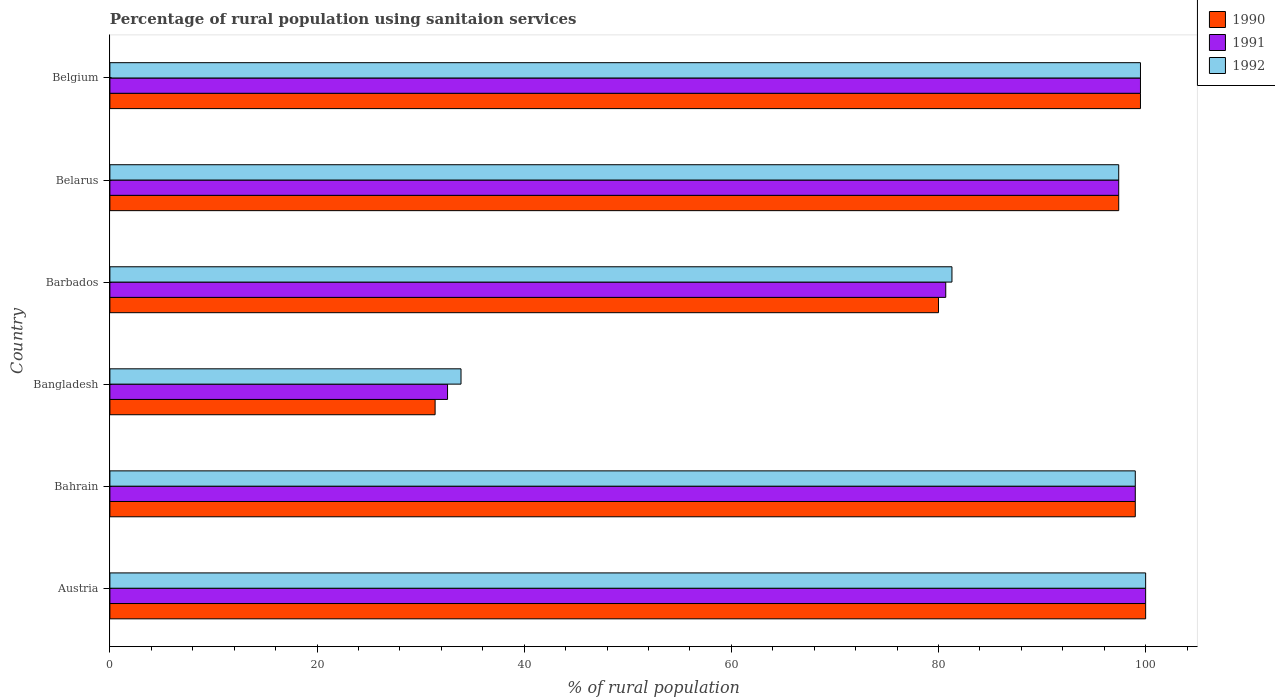Are the number of bars per tick equal to the number of legend labels?
Your answer should be very brief. Yes. How many bars are there on the 4th tick from the bottom?
Give a very brief answer. 3. Across all countries, what is the maximum percentage of rural population using sanitaion services in 1992?
Make the answer very short. 100. Across all countries, what is the minimum percentage of rural population using sanitaion services in 1992?
Offer a terse response. 33.9. In which country was the percentage of rural population using sanitaion services in 1991 maximum?
Provide a succinct answer. Austria. In which country was the percentage of rural population using sanitaion services in 1991 minimum?
Keep it short and to the point. Bangladesh. What is the total percentage of rural population using sanitaion services in 1990 in the graph?
Make the answer very short. 507.3. What is the difference between the percentage of rural population using sanitaion services in 1991 in Barbados and that in Belarus?
Your answer should be very brief. -16.7. What is the difference between the percentage of rural population using sanitaion services in 1990 in Belarus and the percentage of rural population using sanitaion services in 1991 in Bahrain?
Your answer should be very brief. -1.6. What is the average percentage of rural population using sanitaion services in 1992 per country?
Make the answer very short. 85.18. What is the difference between the percentage of rural population using sanitaion services in 1991 and percentage of rural population using sanitaion services in 1992 in Barbados?
Offer a terse response. -0.6. What is the ratio of the percentage of rural population using sanitaion services in 1991 in Austria to that in Belarus?
Give a very brief answer. 1.03. Is the percentage of rural population using sanitaion services in 1992 in Belarus less than that in Belgium?
Offer a very short reply. Yes. Is the difference between the percentage of rural population using sanitaion services in 1991 in Bahrain and Belgium greater than the difference between the percentage of rural population using sanitaion services in 1992 in Bahrain and Belgium?
Offer a terse response. No. What is the difference between the highest and the lowest percentage of rural population using sanitaion services in 1992?
Provide a short and direct response. 66.1. In how many countries, is the percentage of rural population using sanitaion services in 1991 greater than the average percentage of rural population using sanitaion services in 1991 taken over all countries?
Give a very brief answer. 4. Is the sum of the percentage of rural population using sanitaion services in 1992 in Austria and Belarus greater than the maximum percentage of rural population using sanitaion services in 1991 across all countries?
Your answer should be compact. Yes. What does the 2nd bar from the top in Bahrain represents?
Your response must be concise. 1991. Is it the case that in every country, the sum of the percentage of rural population using sanitaion services in 1990 and percentage of rural population using sanitaion services in 1991 is greater than the percentage of rural population using sanitaion services in 1992?
Your response must be concise. Yes. Are all the bars in the graph horizontal?
Provide a succinct answer. Yes. What is the difference between two consecutive major ticks on the X-axis?
Give a very brief answer. 20. Are the values on the major ticks of X-axis written in scientific E-notation?
Offer a very short reply. No. Does the graph contain any zero values?
Your answer should be compact. No. What is the title of the graph?
Ensure brevity in your answer.  Percentage of rural population using sanitaion services. What is the label or title of the X-axis?
Make the answer very short. % of rural population. What is the % of rural population of 1990 in Austria?
Your answer should be compact. 100. What is the % of rural population in 1991 in Austria?
Your answer should be compact. 100. What is the % of rural population of 1990 in Bangladesh?
Provide a short and direct response. 31.4. What is the % of rural population of 1991 in Bangladesh?
Ensure brevity in your answer.  32.6. What is the % of rural population in 1992 in Bangladesh?
Your response must be concise. 33.9. What is the % of rural population in 1991 in Barbados?
Your response must be concise. 80.7. What is the % of rural population of 1992 in Barbados?
Your response must be concise. 81.3. What is the % of rural population in 1990 in Belarus?
Your answer should be very brief. 97.4. What is the % of rural population in 1991 in Belarus?
Ensure brevity in your answer.  97.4. What is the % of rural population of 1992 in Belarus?
Keep it short and to the point. 97.4. What is the % of rural population in 1990 in Belgium?
Offer a terse response. 99.5. What is the % of rural population in 1991 in Belgium?
Offer a terse response. 99.5. What is the % of rural population of 1992 in Belgium?
Provide a short and direct response. 99.5. Across all countries, what is the maximum % of rural population in 1991?
Provide a short and direct response. 100. Across all countries, what is the minimum % of rural population of 1990?
Make the answer very short. 31.4. Across all countries, what is the minimum % of rural population of 1991?
Offer a terse response. 32.6. Across all countries, what is the minimum % of rural population in 1992?
Provide a short and direct response. 33.9. What is the total % of rural population of 1990 in the graph?
Offer a very short reply. 507.3. What is the total % of rural population of 1991 in the graph?
Your response must be concise. 509.2. What is the total % of rural population of 1992 in the graph?
Provide a succinct answer. 511.1. What is the difference between the % of rural population of 1991 in Austria and that in Bahrain?
Your response must be concise. 1. What is the difference between the % of rural population of 1990 in Austria and that in Bangladesh?
Provide a short and direct response. 68.6. What is the difference between the % of rural population in 1991 in Austria and that in Bangladesh?
Offer a terse response. 67.4. What is the difference between the % of rural population in 1992 in Austria and that in Bangladesh?
Your answer should be very brief. 66.1. What is the difference between the % of rural population of 1990 in Austria and that in Barbados?
Make the answer very short. 20. What is the difference between the % of rural population of 1991 in Austria and that in Barbados?
Give a very brief answer. 19.3. What is the difference between the % of rural population in 1992 in Austria and that in Barbados?
Your response must be concise. 18.7. What is the difference between the % of rural population of 1990 in Austria and that in Belarus?
Make the answer very short. 2.6. What is the difference between the % of rural population in 1992 in Austria and that in Belarus?
Your response must be concise. 2.6. What is the difference between the % of rural population in 1991 in Austria and that in Belgium?
Give a very brief answer. 0.5. What is the difference between the % of rural population of 1990 in Bahrain and that in Bangladesh?
Make the answer very short. 67.6. What is the difference between the % of rural population in 1991 in Bahrain and that in Bangladesh?
Your response must be concise. 66.4. What is the difference between the % of rural population in 1992 in Bahrain and that in Bangladesh?
Make the answer very short. 65.1. What is the difference between the % of rural population in 1991 in Bahrain and that in Barbados?
Ensure brevity in your answer.  18.3. What is the difference between the % of rural population of 1991 in Bahrain and that in Belarus?
Your answer should be very brief. 1.6. What is the difference between the % of rural population of 1992 in Bahrain and that in Belarus?
Offer a terse response. 1.6. What is the difference between the % of rural population of 1990 in Bahrain and that in Belgium?
Offer a very short reply. -0.5. What is the difference between the % of rural population of 1991 in Bahrain and that in Belgium?
Ensure brevity in your answer.  -0.5. What is the difference between the % of rural population in 1990 in Bangladesh and that in Barbados?
Give a very brief answer. -48.6. What is the difference between the % of rural population of 1991 in Bangladesh and that in Barbados?
Give a very brief answer. -48.1. What is the difference between the % of rural population of 1992 in Bangladesh and that in Barbados?
Make the answer very short. -47.4. What is the difference between the % of rural population of 1990 in Bangladesh and that in Belarus?
Provide a succinct answer. -66. What is the difference between the % of rural population of 1991 in Bangladesh and that in Belarus?
Offer a terse response. -64.8. What is the difference between the % of rural population of 1992 in Bangladesh and that in Belarus?
Keep it short and to the point. -63.5. What is the difference between the % of rural population in 1990 in Bangladesh and that in Belgium?
Give a very brief answer. -68.1. What is the difference between the % of rural population in 1991 in Bangladesh and that in Belgium?
Offer a very short reply. -66.9. What is the difference between the % of rural population of 1992 in Bangladesh and that in Belgium?
Provide a succinct answer. -65.6. What is the difference between the % of rural population of 1990 in Barbados and that in Belarus?
Ensure brevity in your answer.  -17.4. What is the difference between the % of rural population in 1991 in Barbados and that in Belarus?
Offer a very short reply. -16.7. What is the difference between the % of rural population of 1992 in Barbados and that in Belarus?
Give a very brief answer. -16.1. What is the difference between the % of rural population in 1990 in Barbados and that in Belgium?
Give a very brief answer. -19.5. What is the difference between the % of rural population in 1991 in Barbados and that in Belgium?
Provide a short and direct response. -18.8. What is the difference between the % of rural population of 1992 in Barbados and that in Belgium?
Provide a succinct answer. -18.2. What is the difference between the % of rural population of 1992 in Belarus and that in Belgium?
Provide a short and direct response. -2.1. What is the difference between the % of rural population in 1990 in Austria and the % of rural population in 1992 in Bahrain?
Offer a very short reply. 1. What is the difference between the % of rural population in 1990 in Austria and the % of rural population in 1991 in Bangladesh?
Keep it short and to the point. 67.4. What is the difference between the % of rural population in 1990 in Austria and the % of rural population in 1992 in Bangladesh?
Your response must be concise. 66.1. What is the difference between the % of rural population in 1991 in Austria and the % of rural population in 1992 in Bangladesh?
Keep it short and to the point. 66.1. What is the difference between the % of rural population of 1990 in Austria and the % of rural population of 1991 in Barbados?
Offer a very short reply. 19.3. What is the difference between the % of rural population in 1990 in Austria and the % of rural population in 1992 in Barbados?
Ensure brevity in your answer.  18.7. What is the difference between the % of rural population in 1991 in Austria and the % of rural population in 1992 in Barbados?
Provide a succinct answer. 18.7. What is the difference between the % of rural population of 1991 in Austria and the % of rural population of 1992 in Belarus?
Offer a terse response. 2.6. What is the difference between the % of rural population of 1990 in Austria and the % of rural population of 1992 in Belgium?
Offer a very short reply. 0.5. What is the difference between the % of rural population of 1991 in Austria and the % of rural population of 1992 in Belgium?
Your response must be concise. 0.5. What is the difference between the % of rural population of 1990 in Bahrain and the % of rural population of 1991 in Bangladesh?
Provide a succinct answer. 66.4. What is the difference between the % of rural population in 1990 in Bahrain and the % of rural population in 1992 in Bangladesh?
Make the answer very short. 65.1. What is the difference between the % of rural population in 1991 in Bahrain and the % of rural population in 1992 in Bangladesh?
Your answer should be very brief. 65.1. What is the difference between the % of rural population in 1990 in Bahrain and the % of rural population in 1992 in Barbados?
Provide a short and direct response. 17.7. What is the difference between the % of rural population in 1991 in Bahrain and the % of rural population in 1992 in Barbados?
Make the answer very short. 17.7. What is the difference between the % of rural population in 1990 in Bahrain and the % of rural population in 1991 in Belgium?
Your response must be concise. -0.5. What is the difference between the % of rural population of 1991 in Bahrain and the % of rural population of 1992 in Belgium?
Ensure brevity in your answer.  -0.5. What is the difference between the % of rural population in 1990 in Bangladesh and the % of rural population in 1991 in Barbados?
Ensure brevity in your answer.  -49.3. What is the difference between the % of rural population in 1990 in Bangladesh and the % of rural population in 1992 in Barbados?
Provide a succinct answer. -49.9. What is the difference between the % of rural population in 1991 in Bangladesh and the % of rural population in 1992 in Barbados?
Ensure brevity in your answer.  -48.7. What is the difference between the % of rural population in 1990 in Bangladesh and the % of rural population in 1991 in Belarus?
Provide a short and direct response. -66. What is the difference between the % of rural population in 1990 in Bangladesh and the % of rural population in 1992 in Belarus?
Provide a short and direct response. -66. What is the difference between the % of rural population of 1991 in Bangladesh and the % of rural population of 1992 in Belarus?
Provide a succinct answer. -64.8. What is the difference between the % of rural population of 1990 in Bangladesh and the % of rural population of 1991 in Belgium?
Make the answer very short. -68.1. What is the difference between the % of rural population in 1990 in Bangladesh and the % of rural population in 1992 in Belgium?
Make the answer very short. -68.1. What is the difference between the % of rural population of 1991 in Bangladesh and the % of rural population of 1992 in Belgium?
Provide a short and direct response. -66.9. What is the difference between the % of rural population of 1990 in Barbados and the % of rural population of 1991 in Belarus?
Your answer should be very brief. -17.4. What is the difference between the % of rural population in 1990 in Barbados and the % of rural population in 1992 in Belarus?
Give a very brief answer. -17.4. What is the difference between the % of rural population in 1991 in Barbados and the % of rural population in 1992 in Belarus?
Make the answer very short. -16.7. What is the difference between the % of rural population of 1990 in Barbados and the % of rural population of 1991 in Belgium?
Provide a succinct answer. -19.5. What is the difference between the % of rural population of 1990 in Barbados and the % of rural population of 1992 in Belgium?
Ensure brevity in your answer.  -19.5. What is the difference between the % of rural population of 1991 in Barbados and the % of rural population of 1992 in Belgium?
Your answer should be very brief. -18.8. What is the average % of rural population of 1990 per country?
Your response must be concise. 84.55. What is the average % of rural population of 1991 per country?
Keep it short and to the point. 84.87. What is the average % of rural population of 1992 per country?
Offer a very short reply. 85.18. What is the difference between the % of rural population of 1990 and % of rural population of 1991 in Austria?
Provide a succinct answer. 0. What is the difference between the % of rural population of 1991 and % of rural population of 1992 in Austria?
Offer a very short reply. 0. What is the difference between the % of rural population of 1990 and % of rural population of 1992 in Bahrain?
Your answer should be compact. 0. What is the difference between the % of rural population of 1991 and % of rural population of 1992 in Bahrain?
Offer a very short reply. 0. What is the difference between the % of rural population of 1990 and % of rural population of 1992 in Belarus?
Make the answer very short. 0. What is the difference between the % of rural population in 1991 and % of rural population in 1992 in Belarus?
Offer a very short reply. 0. What is the ratio of the % of rural population in 1990 in Austria to that in Bahrain?
Provide a succinct answer. 1.01. What is the ratio of the % of rural population of 1991 in Austria to that in Bahrain?
Your answer should be very brief. 1.01. What is the ratio of the % of rural population in 1992 in Austria to that in Bahrain?
Offer a terse response. 1.01. What is the ratio of the % of rural population in 1990 in Austria to that in Bangladesh?
Provide a short and direct response. 3.18. What is the ratio of the % of rural population in 1991 in Austria to that in Bangladesh?
Make the answer very short. 3.07. What is the ratio of the % of rural population in 1992 in Austria to that in Bangladesh?
Offer a very short reply. 2.95. What is the ratio of the % of rural population of 1990 in Austria to that in Barbados?
Give a very brief answer. 1.25. What is the ratio of the % of rural population in 1991 in Austria to that in Barbados?
Offer a terse response. 1.24. What is the ratio of the % of rural population of 1992 in Austria to that in Barbados?
Provide a short and direct response. 1.23. What is the ratio of the % of rural population in 1990 in Austria to that in Belarus?
Ensure brevity in your answer.  1.03. What is the ratio of the % of rural population in 1991 in Austria to that in Belarus?
Keep it short and to the point. 1.03. What is the ratio of the % of rural population in 1992 in Austria to that in Belarus?
Your answer should be very brief. 1.03. What is the ratio of the % of rural population in 1990 in Austria to that in Belgium?
Provide a short and direct response. 1. What is the ratio of the % of rural population of 1992 in Austria to that in Belgium?
Make the answer very short. 1. What is the ratio of the % of rural population in 1990 in Bahrain to that in Bangladesh?
Provide a succinct answer. 3.15. What is the ratio of the % of rural population of 1991 in Bahrain to that in Bangladesh?
Your answer should be compact. 3.04. What is the ratio of the % of rural population of 1992 in Bahrain to that in Bangladesh?
Your answer should be compact. 2.92. What is the ratio of the % of rural population in 1990 in Bahrain to that in Barbados?
Your answer should be very brief. 1.24. What is the ratio of the % of rural population in 1991 in Bahrain to that in Barbados?
Your answer should be compact. 1.23. What is the ratio of the % of rural population of 1992 in Bahrain to that in Barbados?
Make the answer very short. 1.22. What is the ratio of the % of rural population of 1990 in Bahrain to that in Belarus?
Your answer should be very brief. 1.02. What is the ratio of the % of rural population of 1991 in Bahrain to that in Belarus?
Your response must be concise. 1.02. What is the ratio of the % of rural population of 1992 in Bahrain to that in Belarus?
Make the answer very short. 1.02. What is the ratio of the % of rural population in 1990 in Bahrain to that in Belgium?
Offer a very short reply. 0.99. What is the ratio of the % of rural population of 1991 in Bahrain to that in Belgium?
Ensure brevity in your answer.  0.99. What is the ratio of the % of rural population in 1990 in Bangladesh to that in Barbados?
Your answer should be compact. 0.39. What is the ratio of the % of rural population of 1991 in Bangladesh to that in Barbados?
Your response must be concise. 0.4. What is the ratio of the % of rural population of 1992 in Bangladesh to that in Barbados?
Provide a short and direct response. 0.42. What is the ratio of the % of rural population of 1990 in Bangladesh to that in Belarus?
Your response must be concise. 0.32. What is the ratio of the % of rural population of 1991 in Bangladesh to that in Belarus?
Make the answer very short. 0.33. What is the ratio of the % of rural population in 1992 in Bangladesh to that in Belarus?
Ensure brevity in your answer.  0.35. What is the ratio of the % of rural population of 1990 in Bangladesh to that in Belgium?
Give a very brief answer. 0.32. What is the ratio of the % of rural population in 1991 in Bangladesh to that in Belgium?
Your answer should be very brief. 0.33. What is the ratio of the % of rural population of 1992 in Bangladesh to that in Belgium?
Ensure brevity in your answer.  0.34. What is the ratio of the % of rural population in 1990 in Barbados to that in Belarus?
Provide a short and direct response. 0.82. What is the ratio of the % of rural population in 1991 in Barbados to that in Belarus?
Ensure brevity in your answer.  0.83. What is the ratio of the % of rural population of 1992 in Barbados to that in Belarus?
Offer a terse response. 0.83. What is the ratio of the % of rural population in 1990 in Barbados to that in Belgium?
Offer a terse response. 0.8. What is the ratio of the % of rural population of 1991 in Barbados to that in Belgium?
Your answer should be compact. 0.81. What is the ratio of the % of rural population of 1992 in Barbados to that in Belgium?
Ensure brevity in your answer.  0.82. What is the ratio of the % of rural population in 1990 in Belarus to that in Belgium?
Your answer should be compact. 0.98. What is the ratio of the % of rural population of 1991 in Belarus to that in Belgium?
Make the answer very short. 0.98. What is the ratio of the % of rural population of 1992 in Belarus to that in Belgium?
Give a very brief answer. 0.98. What is the difference between the highest and the second highest % of rural population of 1991?
Your response must be concise. 0.5. What is the difference between the highest and the lowest % of rural population in 1990?
Offer a terse response. 68.6. What is the difference between the highest and the lowest % of rural population of 1991?
Ensure brevity in your answer.  67.4. What is the difference between the highest and the lowest % of rural population in 1992?
Keep it short and to the point. 66.1. 